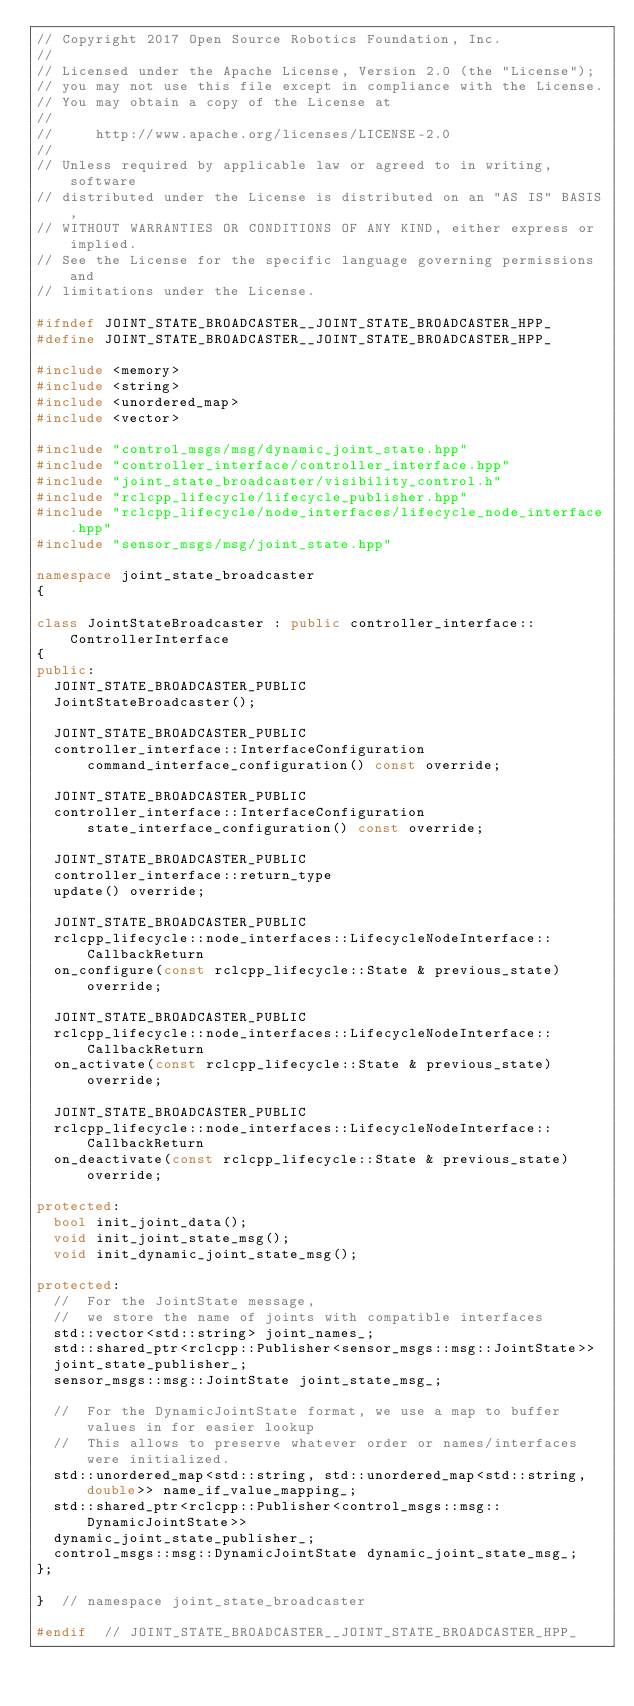Convert code to text. <code><loc_0><loc_0><loc_500><loc_500><_C++_>// Copyright 2017 Open Source Robotics Foundation, Inc.
//
// Licensed under the Apache License, Version 2.0 (the "License");
// you may not use this file except in compliance with the License.
// You may obtain a copy of the License at
//
//     http://www.apache.org/licenses/LICENSE-2.0
//
// Unless required by applicable law or agreed to in writing, software
// distributed under the License is distributed on an "AS IS" BASIS,
// WITHOUT WARRANTIES OR CONDITIONS OF ANY KIND, either express or implied.
// See the License for the specific language governing permissions and
// limitations under the License.

#ifndef JOINT_STATE_BROADCASTER__JOINT_STATE_BROADCASTER_HPP_
#define JOINT_STATE_BROADCASTER__JOINT_STATE_BROADCASTER_HPP_

#include <memory>
#include <string>
#include <unordered_map>
#include <vector>

#include "control_msgs/msg/dynamic_joint_state.hpp"
#include "controller_interface/controller_interface.hpp"
#include "joint_state_broadcaster/visibility_control.h"
#include "rclcpp_lifecycle/lifecycle_publisher.hpp"
#include "rclcpp_lifecycle/node_interfaces/lifecycle_node_interface.hpp"
#include "sensor_msgs/msg/joint_state.hpp"

namespace joint_state_broadcaster
{

class JointStateBroadcaster : public controller_interface::ControllerInterface
{
public:
  JOINT_STATE_BROADCASTER_PUBLIC
  JointStateBroadcaster();

  JOINT_STATE_BROADCASTER_PUBLIC
  controller_interface::InterfaceConfiguration command_interface_configuration() const override;

  JOINT_STATE_BROADCASTER_PUBLIC
  controller_interface::InterfaceConfiguration state_interface_configuration() const override;

  JOINT_STATE_BROADCASTER_PUBLIC
  controller_interface::return_type
  update() override;

  JOINT_STATE_BROADCASTER_PUBLIC
  rclcpp_lifecycle::node_interfaces::LifecycleNodeInterface::CallbackReturn
  on_configure(const rclcpp_lifecycle::State & previous_state) override;

  JOINT_STATE_BROADCASTER_PUBLIC
  rclcpp_lifecycle::node_interfaces::LifecycleNodeInterface::CallbackReturn
  on_activate(const rclcpp_lifecycle::State & previous_state) override;

  JOINT_STATE_BROADCASTER_PUBLIC
  rclcpp_lifecycle::node_interfaces::LifecycleNodeInterface::CallbackReturn
  on_deactivate(const rclcpp_lifecycle::State & previous_state) override;

protected:
  bool init_joint_data();
  void init_joint_state_msg();
  void init_dynamic_joint_state_msg();

protected:
  //  For the JointState message,
  //  we store the name of joints with compatible interfaces
  std::vector<std::string> joint_names_;
  std::shared_ptr<rclcpp::Publisher<sensor_msgs::msg::JointState>>
  joint_state_publisher_;
  sensor_msgs::msg::JointState joint_state_msg_;

  //  For the DynamicJointState format, we use a map to buffer values in for easier lookup
  //  This allows to preserve whatever order or names/interfaces were initialized.
  std::unordered_map<std::string, std::unordered_map<std::string, double>> name_if_value_mapping_;
  std::shared_ptr<rclcpp::Publisher<control_msgs::msg::DynamicJointState>>
  dynamic_joint_state_publisher_;
  control_msgs::msg::DynamicJointState dynamic_joint_state_msg_;
};

}  // namespace joint_state_broadcaster

#endif  // JOINT_STATE_BROADCASTER__JOINT_STATE_BROADCASTER_HPP_
</code> 